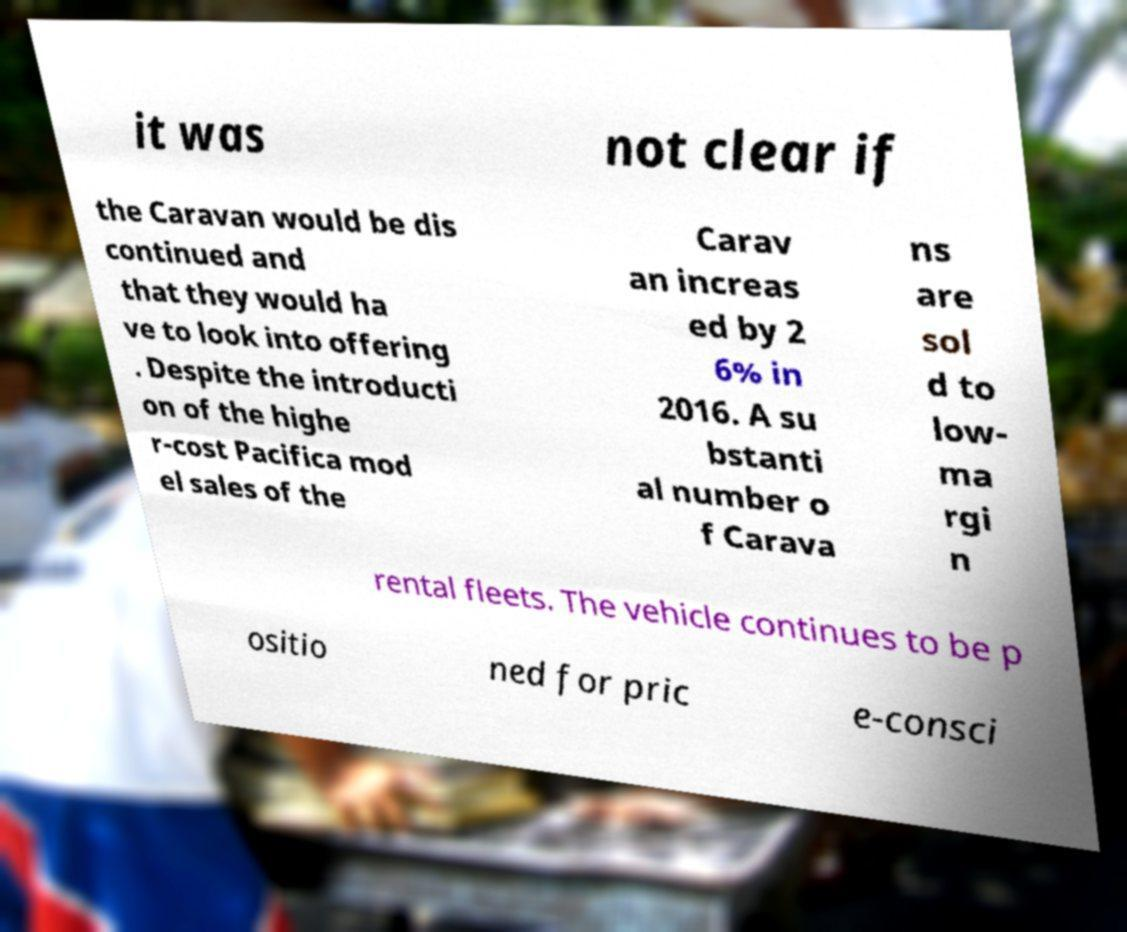Can you accurately transcribe the text from the provided image for me? it was not clear if the Caravan would be dis continued and that they would ha ve to look into offering . Despite the introducti on of the highe r-cost Pacifica mod el sales of the Carav an increas ed by 2 6% in 2016. A su bstanti al number o f Carava ns are sol d to low- ma rgi n rental fleets. The vehicle continues to be p ositio ned for pric e-consci 